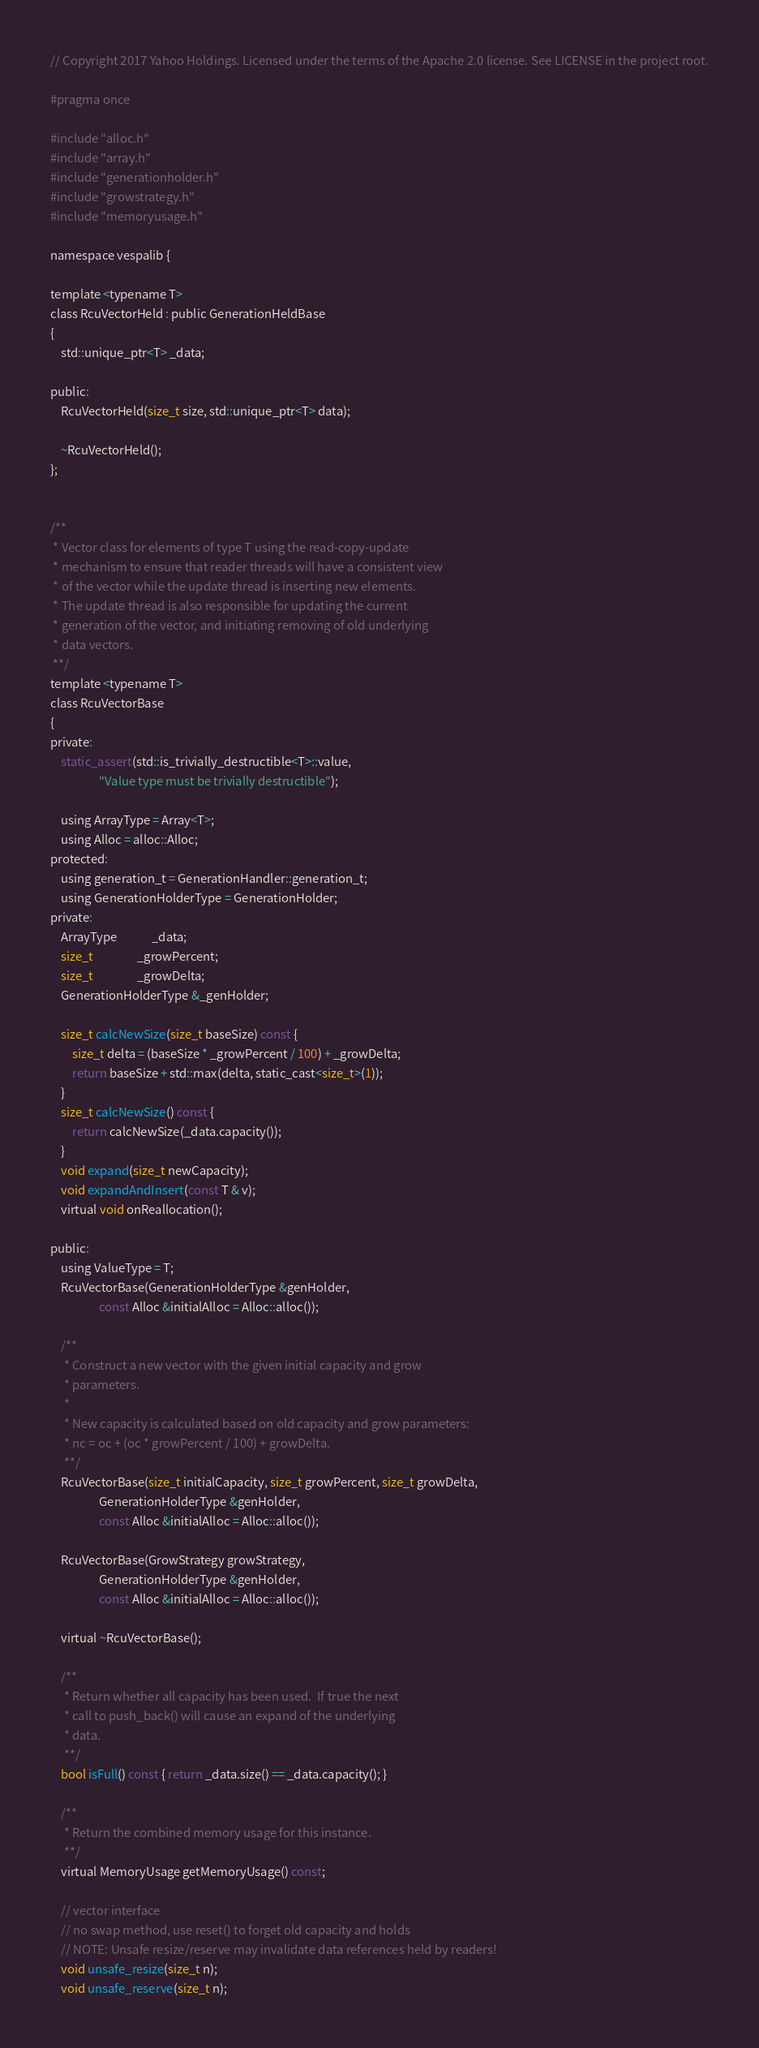<code> <loc_0><loc_0><loc_500><loc_500><_C_>// Copyright 2017 Yahoo Holdings. Licensed under the terms of the Apache 2.0 license. See LICENSE in the project root.

#pragma once

#include "alloc.h"
#include "array.h"
#include "generationholder.h"
#include "growstrategy.h"
#include "memoryusage.h"

namespace vespalib {

template <typename T>
class RcuVectorHeld : public GenerationHeldBase
{
    std::unique_ptr<T> _data;

public:
    RcuVectorHeld(size_t size, std::unique_ptr<T> data);

    ~RcuVectorHeld();
};


/**
 * Vector class for elements of type T using the read-copy-update
 * mechanism to ensure that reader threads will have a consistent view
 * of the vector while the update thread is inserting new elements.
 * The update thread is also responsible for updating the current
 * generation of the vector, and initiating removing of old underlying
 * data vectors.
 **/
template <typename T>
class RcuVectorBase
{
private:
    static_assert(std::is_trivially_destructible<T>::value,
                  "Value type must be trivially destructible");

    using ArrayType = Array<T>;
    using Alloc = alloc::Alloc;
protected:
    using generation_t = GenerationHandler::generation_t;
    using GenerationHolderType = GenerationHolder;
private:
    ArrayType             _data;
    size_t                _growPercent;
    size_t                _growDelta;
    GenerationHolderType &_genHolder;

    size_t calcNewSize(size_t baseSize) const {
        size_t delta = (baseSize * _growPercent / 100) + _growDelta;
        return baseSize + std::max(delta, static_cast<size_t>(1));
    }
    size_t calcNewSize() const {
        return calcNewSize(_data.capacity());
    }
    void expand(size_t newCapacity);
    void expandAndInsert(const T & v);
    virtual void onReallocation();

public:
    using ValueType = T;
    RcuVectorBase(GenerationHolderType &genHolder,
                  const Alloc &initialAlloc = Alloc::alloc());

    /**
     * Construct a new vector with the given initial capacity and grow
     * parameters.
     *
     * New capacity is calculated based on old capacity and grow parameters:
     * nc = oc + (oc * growPercent / 100) + growDelta.
     **/
    RcuVectorBase(size_t initialCapacity, size_t growPercent, size_t growDelta,
                  GenerationHolderType &genHolder,
                  const Alloc &initialAlloc = Alloc::alloc());

    RcuVectorBase(GrowStrategy growStrategy,
                  GenerationHolderType &genHolder,
                  const Alloc &initialAlloc = Alloc::alloc());

    virtual ~RcuVectorBase();

    /**
     * Return whether all capacity has been used.  If true the next
     * call to push_back() will cause an expand of the underlying
     * data.
     **/
    bool isFull() const { return _data.size() == _data.capacity(); }

    /**
     * Return the combined memory usage for this instance.
     **/
    virtual MemoryUsage getMemoryUsage() const;

    // vector interface
    // no swap method, use reset() to forget old capacity and holds
    // NOTE: Unsafe resize/reserve may invalidate data references held by readers!
    void unsafe_resize(size_t n);
    void unsafe_reserve(size_t n);</code> 